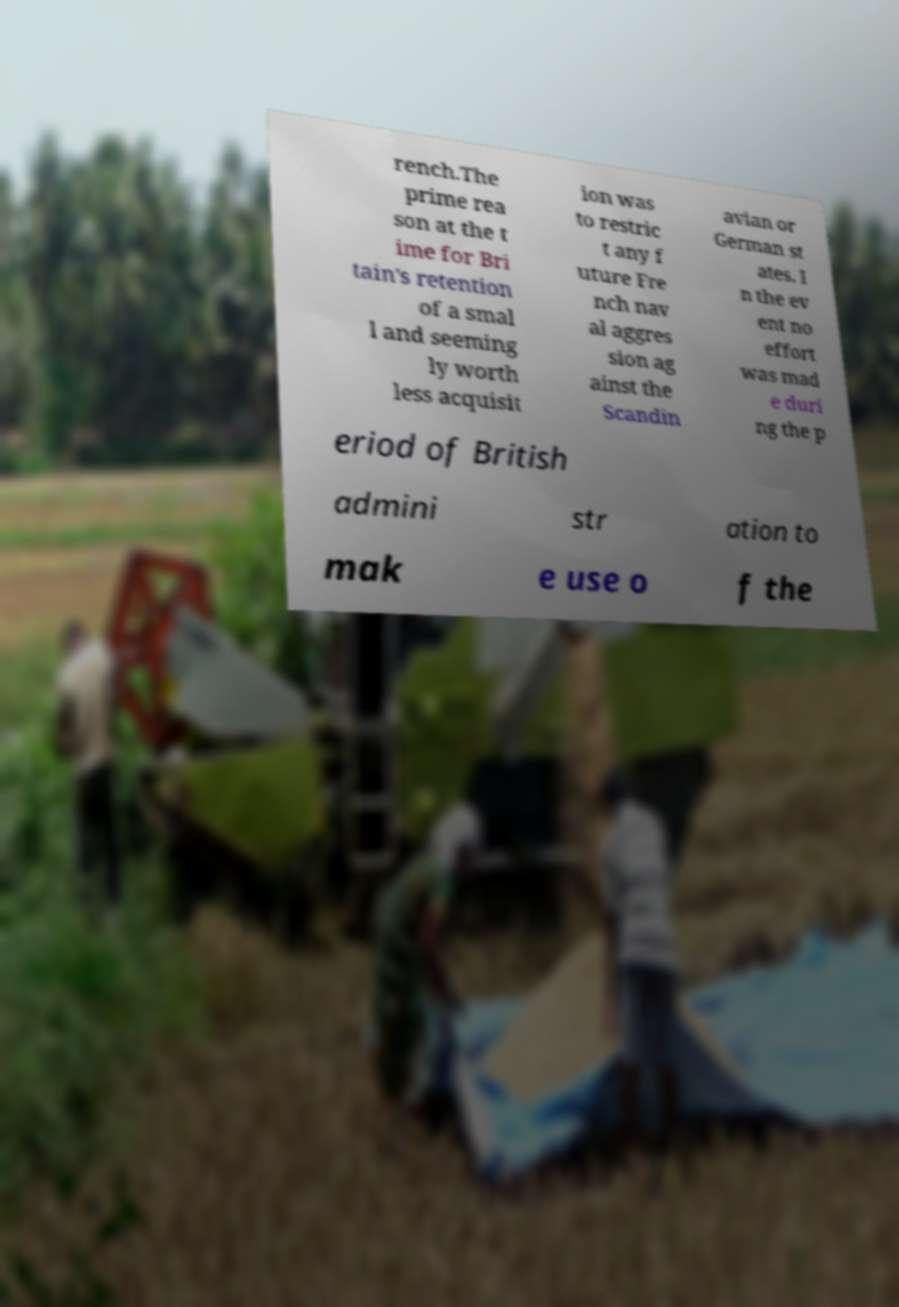Can you read and provide the text displayed in the image?This photo seems to have some interesting text. Can you extract and type it out for me? rench.The prime rea son at the t ime for Bri tain's retention of a smal l and seeming ly worth less acquisit ion was to restric t any f uture Fre nch nav al aggres sion ag ainst the Scandin avian or German st ates. I n the ev ent no effort was mad e duri ng the p eriod of British admini str ation to mak e use o f the 